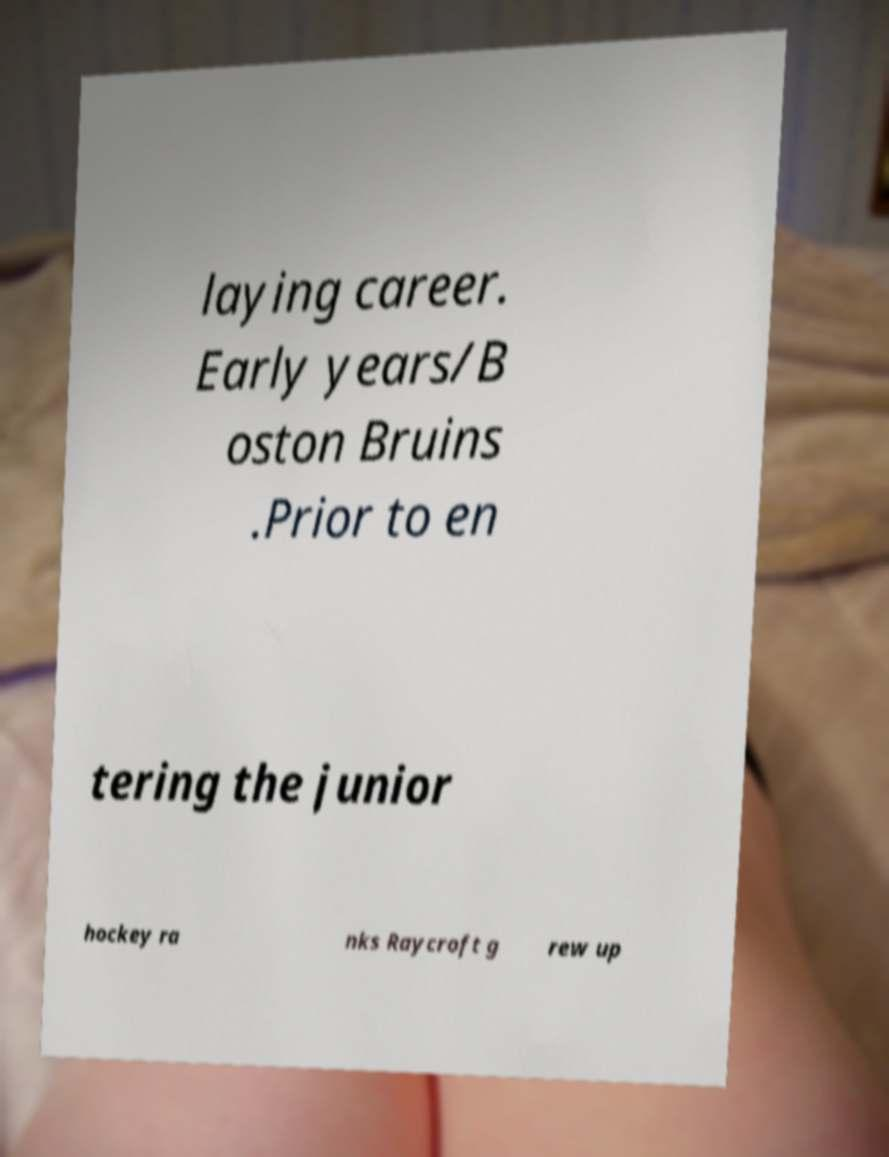For documentation purposes, I need the text within this image transcribed. Could you provide that? laying career. Early years/B oston Bruins .Prior to en tering the junior hockey ra nks Raycroft g rew up 